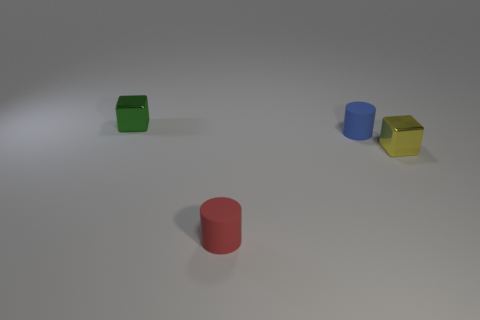Are there fewer tiny metal objects that are in front of the yellow metallic thing than red cylinders?
Give a very brief answer. Yes. Does the yellow object have the same shape as the red matte object?
Provide a succinct answer. No. What number of metal objects are tiny blocks or blue objects?
Keep it short and to the point. 2. Is there another matte object that has the same size as the blue thing?
Provide a short and direct response. Yes. What number of yellow metal blocks have the same size as the blue rubber thing?
Offer a terse response. 1. There is a blue matte object that is on the left side of the yellow block; does it have the same size as the yellow thing in front of the tiny green shiny cube?
Your response must be concise. Yes. How many objects are either green metallic blocks or small cylinders that are in front of the small yellow thing?
Provide a succinct answer. 2. There is a blue thing behind the small thing that is in front of the small yellow metal object that is in front of the green thing; what is it made of?
Your response must be concise. Rubber. What size is the red cylinder that is the same material as the blue cylinder?
Ensure brevity in your answer.  Small. There is a red rubber cylinder; is its size the same as the matte object that is behind the yellow thing?
Keep it short and to the point. Yes. 